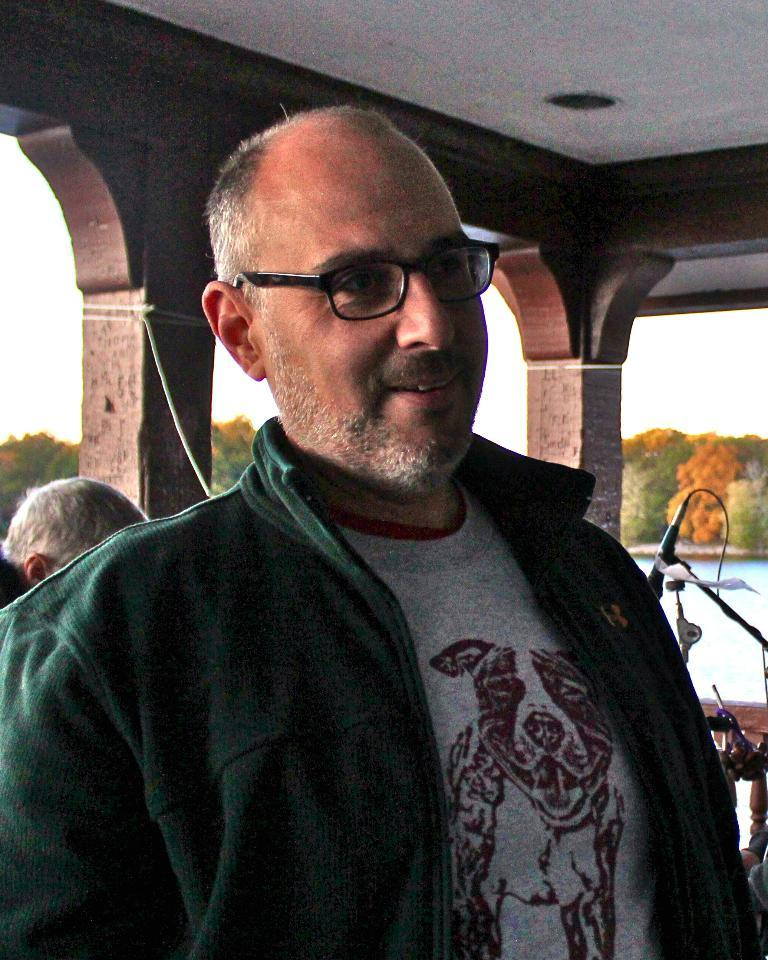What is happening in the image? There are people standing in the image. What object is present that might be used for amplifying sound? There is a microphone on a stand in the image. What natural elements can be seen in the background of the image? There is a river and trees visible in the background of the image. How is the background of the image depicted? The background of the image is slightly blurred. What type of leaf is being rubbed on the microphone in the image? There is no leaf or rubbing action present in the image; the microphone is on a stand and not being interacted with in any way. 